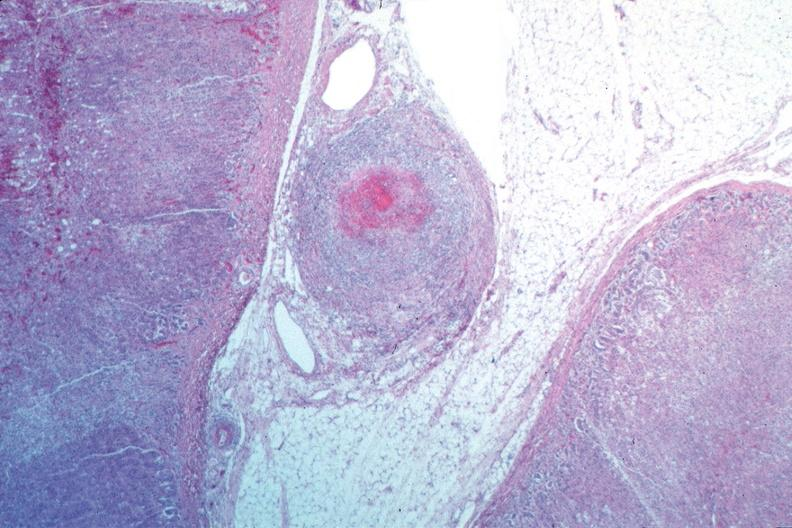does this image show vasculitis, polyarteritis nodosa?
Answer the question using a single word or phrase. Yes 